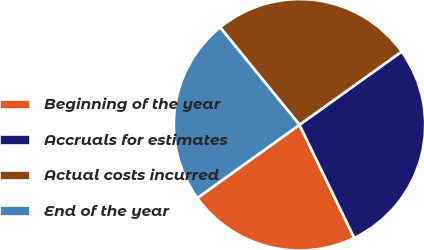Convert chart. <chart><loc_0><loc_0><loc_500><loc_500><pie_chart><fcel>Beginning of the year<fcel>Accruals for estimates<fcel>Actual costs incurred<fcel>End of the year<nl><fcel>22.28%<fcel>27.72%<fcel>25.99%<fcel>24.01%<nl></chart> 